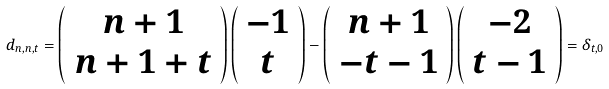<formula> <loc_0><loc_0><loc_500><loc_500>d _ { n , n , t } = \left ( \begin{array} { c } n + 1 \\ n + 1 + t \end{array} \right ) \left ( \begin{array} { c } - 1 \\ t \end{array} \right ) - \left ( \begin{array} { c } n + 1 \\ - t - 1 \end{array} \right ) \left ( \begin{array} { c } - 2 \\ t - 1 \end{array} \right ) = \delta _ { t , 0 }</formula> 